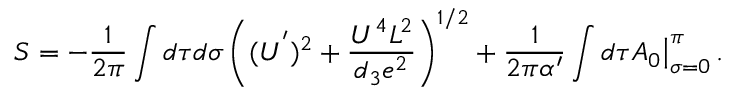<formula> <loc_0><loc_0><loc_500><loc_500>S = - { \frac { 1 } { 2 \pi } } \int d \tau d \sigma \left ( ( U ^ { ^ { \prime } } ) ^ { 2 } + \frac { U ^ { 4 } L ^ { 2 } } { d _ { 3 } e ^ { 2 } } \right ) ^ { 1 / 2 } + { \frac { 1 } { 2 \pi \alpha ^ { \prime } } } \int d \tau A _ { 0 } \Big | _ { \sigma = 0 } ^ { \pi } \, .</formula> 